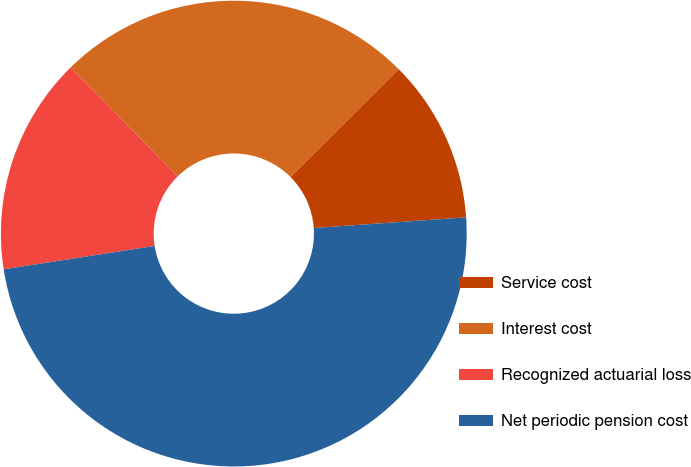Convert chart. <chart><loc_0><loc_0><loc_500><loc_500><pie_chart><fcel>Service cost<fcel>Interest cost<fcel>Recognized actuarial loss<fcel>Net periodic pension cost<nl><fcel>11.37%<fcel>24.87%<fcel>15.1%<fcel>48.65%<nl></chart> 